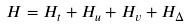Convert formula to latex. <formula><loc_0><loc_0><loc_500><loc_500>H = H _ { t } + H _ { u } + H _ { v } + H _ { \Delta }</formula> 